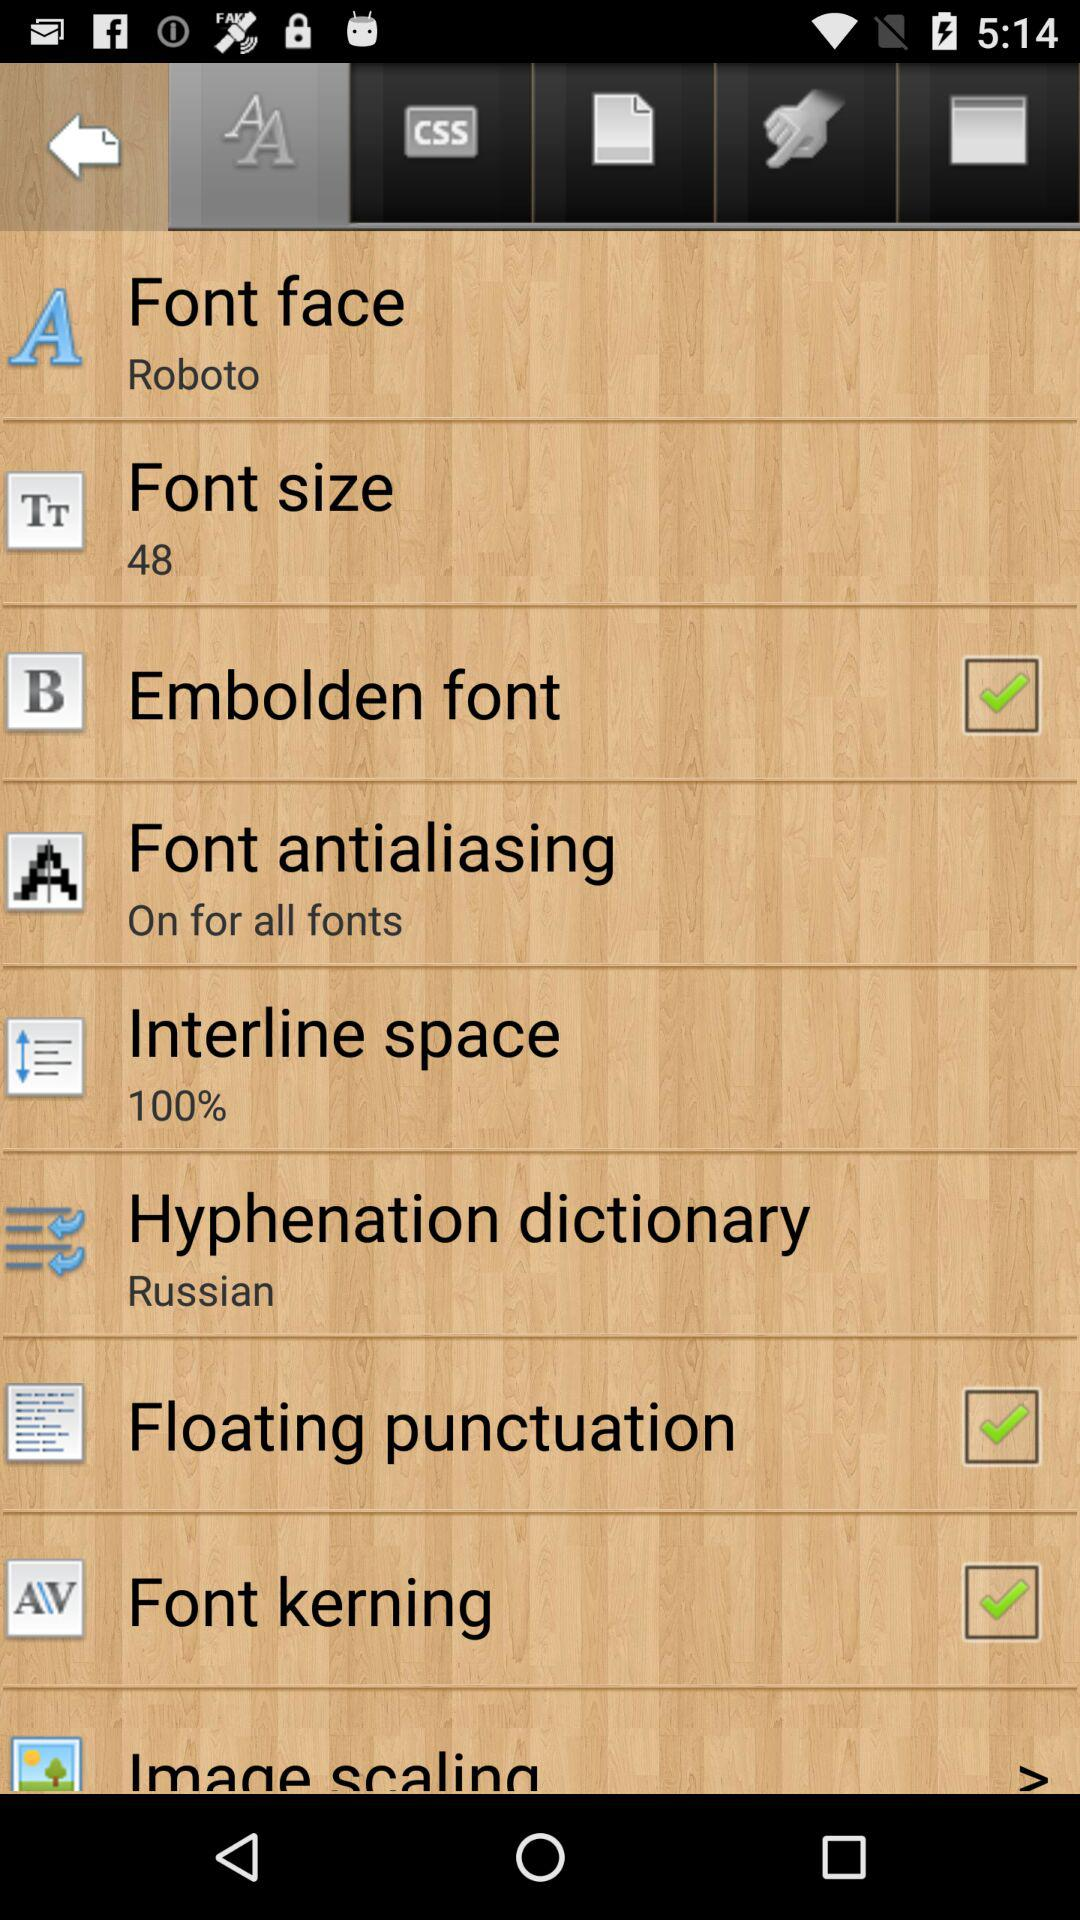What is the status of floating punctuation? The status of floating punctuation is on. 